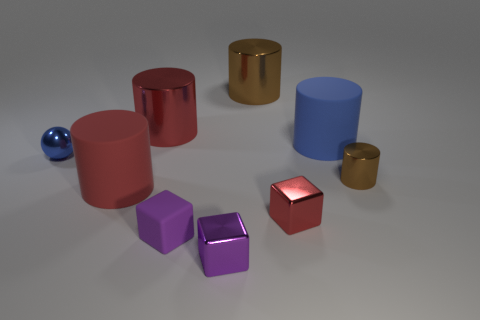Subtract 1 cylinders. How many cylinders are left? 4 Subtract all blue cylinders. How many cylinders are left? 4 Subtract all tiny brown metal cylinders. How many cylinders are left? 4 Subtract all yellow cylinders. Subtract all purple cubes. How many cylinders are left? 5 Subtract all cubes. How many objects are left? 6 Add 1 red cubes. How many red cubes exist? 2 Subtract 0 brown balls. How many objects are left? 9 Subtract all purple rubber objects. Subtract all big red rubber cylinders. How many objects are left? 7 Add 6 large brown things. How many large brown things are left? 7 